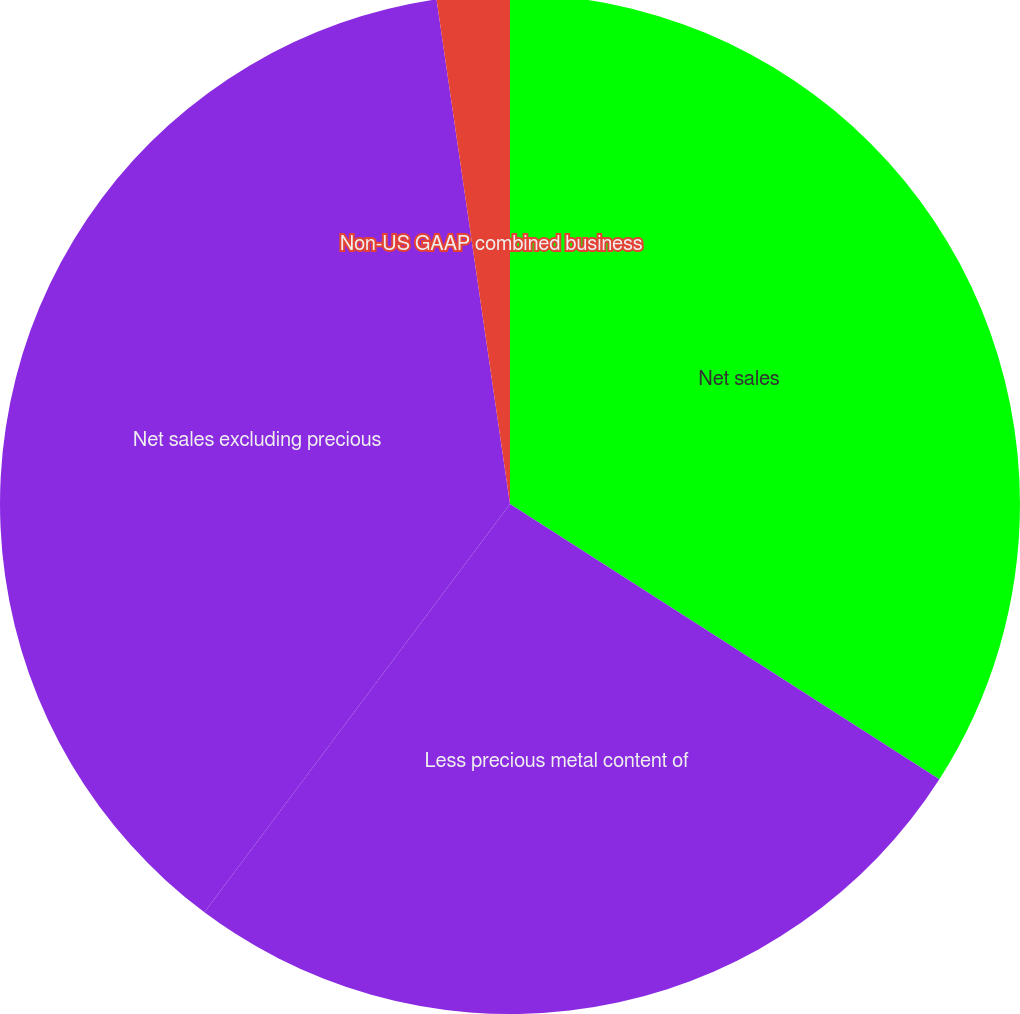<chart> <loc_0><loc_0><loc_500><loc_500><pie_chart><fcel>Net sales<fcel>Less precious metal content of<fcel>Net sales excluding precious<fcel>Non-US GAAP combined business<nl><fcel>34.07%<fcel>26.15%<fcel>37.47%<fcel>2.3%<nl></chart> 